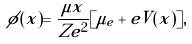Convert formula to latex. <formula><loc_0><loc_0><loc_500><loc_500>\phi ( x ) = \frac { \mu x } { Z e ^ { 2 } } [ \mu _ { e } + e V ( x ) ] ,</formula> 